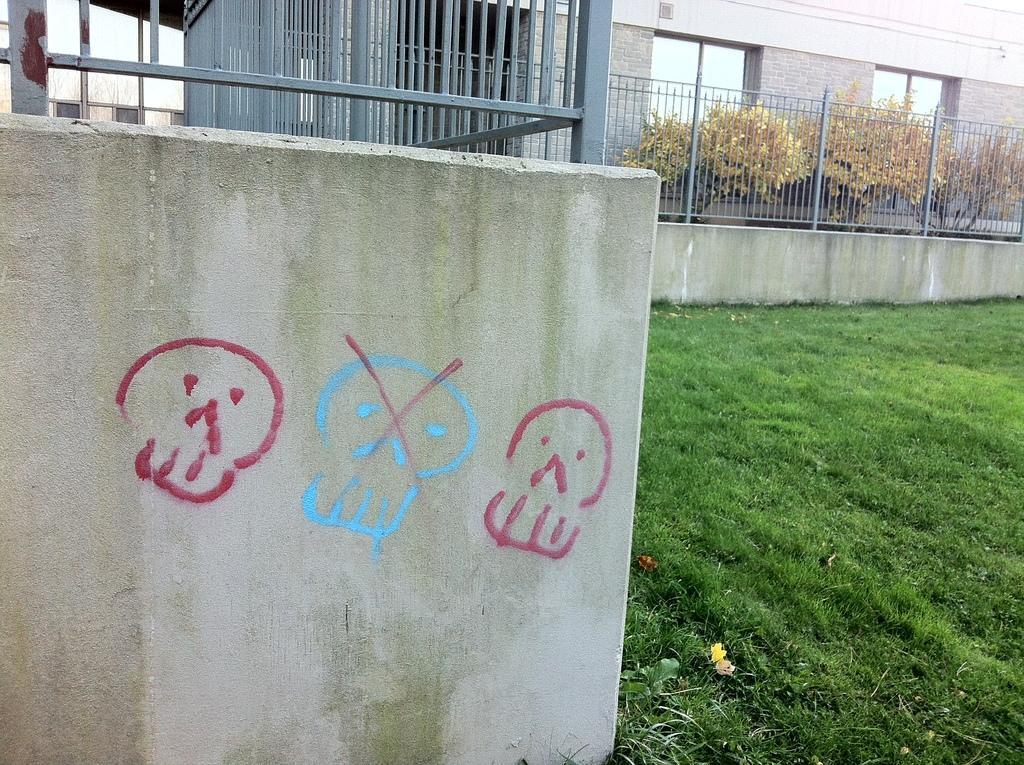Describe this image in one or two sentences. In the center of the image we can see the paintings on the wall. On the right side of the image we can see grass field. In the background, we can see a railing, building with windows, a group of trees and the sky. 